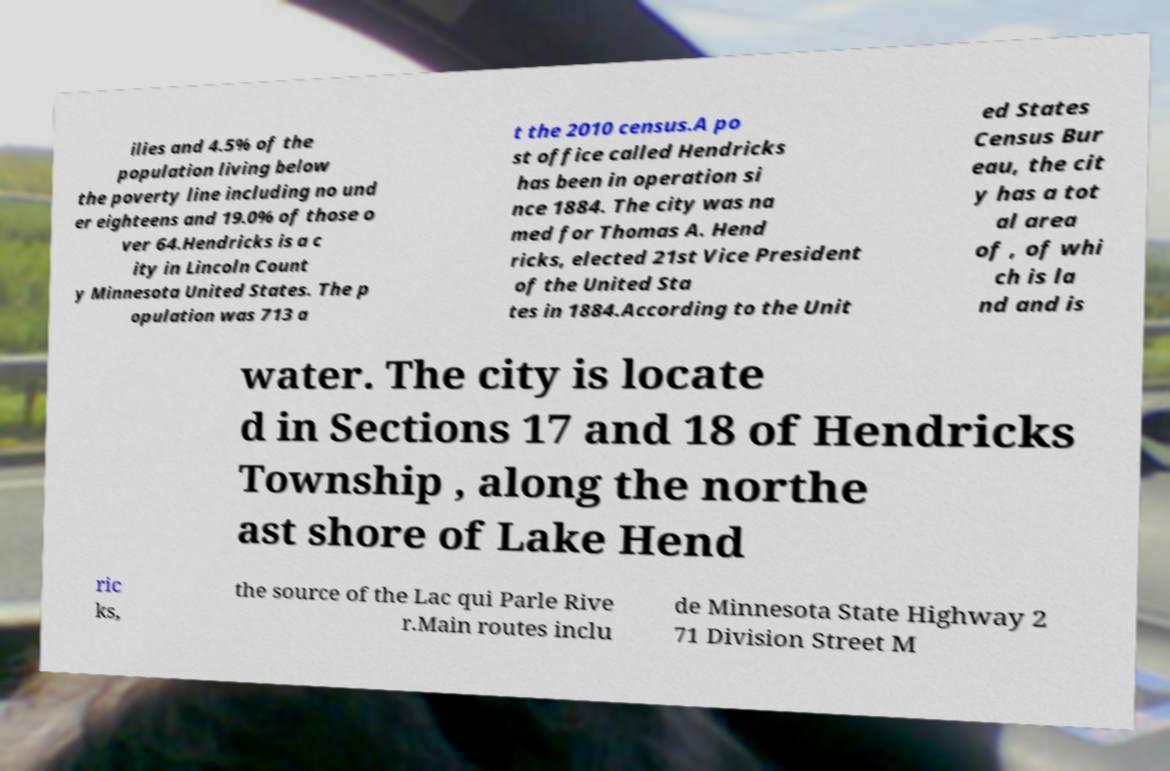Can you accurately transcribe the text from the provided image for me? ilies and 4.5% of the population living below the poverty line including no und er eighteens and 19.0% of those o ver 64.Hendricks is a c ity in Lincoln Count y Minnesota United States. The p opulation was 713 a t the 2010 census.A po st office called Hendricks has been in operation si nce 1884. The city was na med for Thomas A. Hend ricks, elected 21st Vice President of the United Sta tes in 1884.According to the Unit ed States Census Bur eau, the cit y has a tot al area of , of whi ch is la nd and is water. The city is locate d in Sections 17 and 18 of Hendricks Township , along the northe ast shore of Lake Hend ric ks, the source of the Lac qui Parle Rive r.Main routes inclu de Minnesota State Highway 2 71 Division Street M 